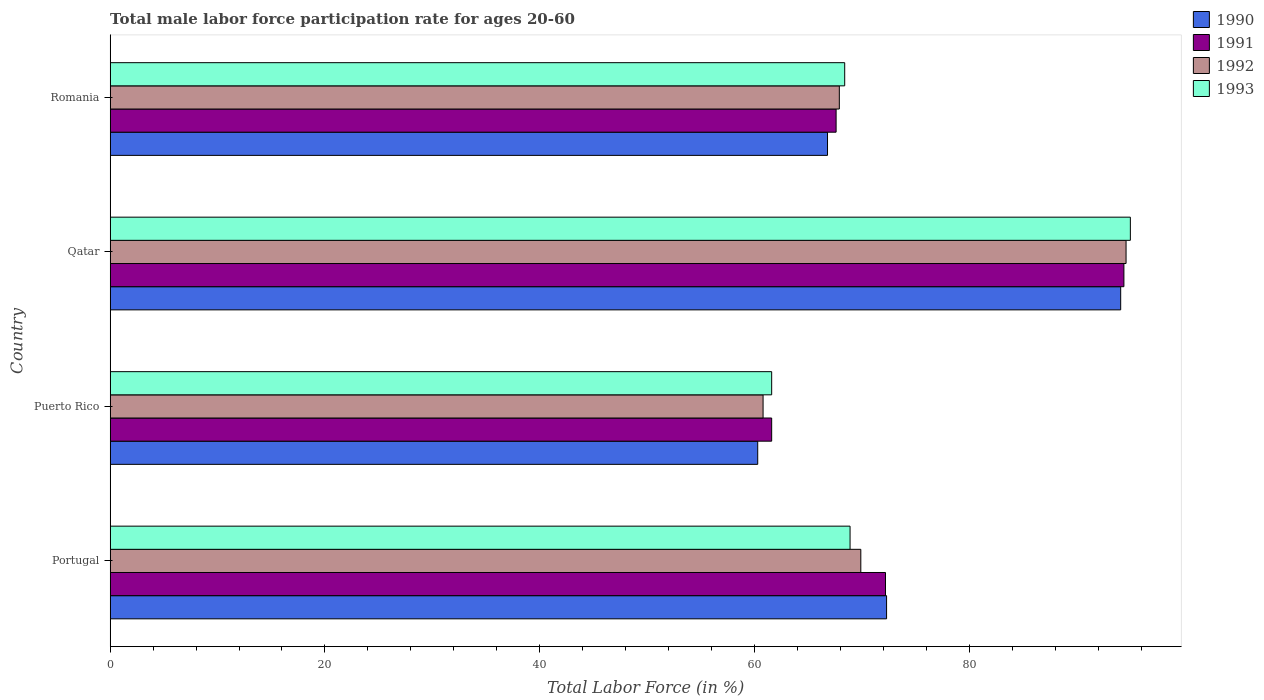How many different coloured bars are there?
Give a very brief answer. 4. Are the number of bars per tick equal to the number of legend labels?
Your response must be concise. Yes. How many bars are there on the 3rd tick from the top?
Your answer should be very brief. 4. How many bars are there on the 1st tick from the bottom?
Your answer should be very brief. 4. What is the male labor force participation rate in 1993 in Puerto Rico?
Provide a short and direct response. 61.6. Across all countries, what is the maximum male labor force participation rate in 1991?
Keep it short and to the point. 94.4. Across all countries, what is the minimum male labor force participation rate in 1990?
Your answer should be compact. 60.3. In which country was the male labor force participation rate in 1992 maximum?
Provide a succinct answer. Qatar. In which country was the male labor force participation rate in 1992 minimum?
Make the answer very short. Puerto Rico. What is the total male labor force participation rate in 1993 in the graph?
Offer a very short reply. 293.9. What is the average male labor force participation rate in 1990 per country?
Provide a succinct answer. 73.38. What is the difference between the male labor force participation rate in 1992 and male labor force participation rate in 1990 in Portugal?
Your answer should be compact. -2.4. What is the ratio of the male labor force participation rate in 1991 in Puerto Rico to that in Qatar?
Provide a short and direct response. 0.65. Is the difference between the male labor force participation rate in 1992 in Portugal and Romania greater than the difference between the male labor force participation rate in 1990 in Portugal and Romania?
Offer a terse response. No. What is the difference between the highest and the second highest male labor force participation rate in 1992?
Your response must be concise. 24.7. What is the difference between the highest and the lowest male labor force participation rate in 1993?
Make the answer very short. 33.4. In how many countries, is the male labor force participation rate in 1993 greater than the average male labor force participation rate in 1993 taken over all countries?
Offer a terse response. 1. Is the sum of the male labor force participation rate in 1991 in Portugal and Qatar greater than the maximum male labor force participation rate in 1993 across all countries?
Make the answer very short. Yes. Is it the case that in every country, the sum of the male labor force participation rate in 1993 and male labor force participation rate in 1990 is greater than the sum of male labor force participation rate in 1992 and male labor force participation rate in 1991?
Your answer should be very brief. No. How many bars are there?
Make the answer very short. 16. Are all the bars in the graph horizontal?
Make the answer very short. Yes. What is the difference between two consecutive major ticks on the X-axis?
Provide a short and direct response. 20. Does the graph contain any zero values?
Keep it short and to the point. No. Does the graph contain grids?
Offer a very short reply. No. How many legend labels are there?
Keep it short and to the point. 4. How are the legend labels stacked?
Give a very brief answer. Vertical. What is the title of the graph?
Provide a succinct answer. Total male labor force participation rate for ages 20-60. What is the label or title of the Y-axis?
Ensure brevity in your answer.  Country. What is the Total Labor Force (in %) of 1990 in Portugal?
Keep it short and to the point. 72.3. What is the Total Labor Force (in %) of 1991 in Portugal?
Offer a terse response. 72.2. What is the Total Labor Force (in %) in 1992 in Portugal?
Give a very brief answer. 69.9. What is the Total Labor Force (in %) in 1993 in Portugal?
Keep it short and to the point. 68.9. What is the Total Labor Force (in %) in 1990 in Puerto Rico?
Make the answer very short. 60.3. What is the Total Labor Force (in %) of 1991 in Puerto Rico?
Offer a terse response. 61.6. What is the Total Labor Force (in %) of 1992 in Puerto Rico?
Give a very brief answer. 60.8. What is the Total Labor Force (in %) in 1993 in Puerto Rico?
Provide a succinct answer. 61.6. What is the Total Labor Force (in %) in 1990 in Qatar?
Your answer should be compact. 94.1. What is the Total Labor Force (in %) in 1991 in Qatar?
Provide a succinct answer. 94.4. What is the Total Labor Force (in %) in 1992 in Qatar?
Offer a terse response. 94.6. What is the Total Labor Force (in %) in 1990 in Romania?
Make the answer very short. 66.8. What is the Total Labor Force (in %) of 1991 in Romania?
Ensure brevity in your answer.  67.6. What is the Total Labor Force (in %) of 1992 in Romania?
Offer a very short reply. 67.9. What is the Total Labor Force (in %) of 1993 in Romania?
Offer a terse response. 68.4. Across all countries, what is the maximum Total Labor Force (in %) in 1990?
Your answer should be very brief. 94.1. Across all countries, what is the maximum Total Labor Force (in %) of 1991?
Provide a short and direct response. 94.4. Across all countries, what is the maximum Total Labor Force (in %) of 1992?
Offer a very short reply. 94.6. Across all countries, what is the maximum Total Labor Force (in %) of 1993?
Offer a terse response. 95. Across all countries, what is the minimum Total Labor Force (in %) of 1990?
Give a very brief answer. 60.3. Across all countries, what is the minimum Total Labor Force (in %) in 1991?
Make the answer very short. 61.6. Across all countries, what is the minimum Total Labor Force (in %) in 1992?
Provide a succinct answer. 60.8. Across all countries, what is the minimum Total Labor Force (in %) in 1993?
Keep it short and to the point. 61.6. What is the total Total Labor Force (in %) of 1990 in the graph?
Provide a succinct answer. 293.5. What is the total Total Labor Force (in %) of 1991 in the graph?
Provide a succinct answer. 295.8. What is the total Total Labor Force (in %) of 1992 in the graph?
Your answer should be very brief. 293.2. What is the total Total Labor Force (in %) of 1993 in the graph?
Offer a very short reply. 293.9. What is the difference between the Total Labor Force (in %) in 1991 in Portugal and that in Puerto Rico?
Offer a terse response. 10.6. What is the difference between the Total Labor Force (in %) of 1993 in Portugal and that in Puerto Rico?
Ensure brevity in your answer.  7.3. What is the difference between the Total Labor Force (in %) of 1990 in Portugal and that in Qatar?
Give a very brief answer. -21.8. What is the difference between the Total Labor Force (in %) of 1991 in Portugal and that in Qatar?
Give a very brief answer. -22.2. What is the difference between the Total Labor Force (in %) in 1992 in Portugal and that in Qatar?
Offer a terse response. -24.7. What is the difference between the Total Labor Force (in %) in 1993 in Portugal and that in Qatar?
Provide a short and direct response. -26.1. What is the difference between the Total Labor Force (in %) of 1990 in Portugal and that in Romania?
Give a very brief answer. 5.5. What is the difference between the Total Labor Force (in %) of 1991 in Portugal and that in Romania?
Offer a terse response. 4.6. What is the difference between the Total Labor Force (in %) of 1992 in Portugal and that in Romania?
Give a very brief answer. 2. What is the difference between the Total Labor Force (in %) in 1993 in Portugal and that in Romania?
Make the answer very short. 0.5. What is the difference between the Total Labor Force (in %) of 1990 in Puerto Rico and that in Qatar?
Make the answer very short. -33.8. What is the difference between the Total Labor Force (in %) of 1991 in Puerto Rico and that in Qatar?
Provide a short and direct response. -32.8. What is the difference between the Total Labor Force (in %) in 1992 in Puerto Rico and that in Qatar?
Provide a short and direct response. -33.8. What is the difference between the Total Labor Force (in %) in 1993 in Puerto Rico and that in Qatar?
Keep it short and to the point. -33.4. What is the difference between the Total Labor Force (in %) of 1991 in Puerto Rico and that in Romania?
Give a very brief answer. -6. What is the difference between the Total Labor Force (in %) in 1990 in Qatar and that in Romania?
Offer a terse response. 27.3. What is the difference between the Total Labor Force (in %) in 1991 in Qatar and that in Romania?
Keep it short and to the point. 26.8. What is the difference between the Total Labor Force (in %) in 1992 in Qatar and that in Romania?
Keep it short and to the point. 26.7. What is the difference between the Total Labor Force (in %) in 1993 in Qatar and that in Romania?
Your answer should be very brief. 26.6. What is the difference between the Total Labor Force (in %) in 1990 in Portugal and the Total Labor Force (in %) in 1993 in Puerto Rico?
Give a very brief answer. 10.7. What is the difference between the Total Labor Force (in %) of 1991 in Portugal and the Total Labor Force (in %) of 1992 in Puerto Rico?
Offer a terse response. 11.4. What is the difference between the Total Labor Force (in %) of 1990 in Portugal and the Total Labor Force (in %) of 1991 in Qatar?
Your response must be concise. -22.1. What is the difference between the Total Labor Force (in %) of 1990 in Portugal and the Total Labor Force (in %) of 1992 in Qatar?
Offer a terse response. -22.3. What is the difference between the Total Labor Force (in %) of 1990 in Portugal and the Total Labor Force (in %) of 1993 in Qatar?
Provide a succinct answer. -22.7. What is the difference between the Total Labor Force (in %) of 1991 in Portugal and the Total Labor Force (in %) of 1992 in Qatar?
Keep it short and to the point. -22.4. What is the difference between the Total Labor Force (in %) of 1991 in Portugal and the Total Labor Force (in %) of 1993 in Qatar?
Offer a terse response. -22.8. What is the difference between the Total Labor Force (in %) of 1992 in Portugal and the Total Labor Force (in %) of 1993 in Qatar?
Offer a very short reply. -25.1. What is the difference between the Total Labor Force (in %) of 1990 in Portugal and the Total Labor Force (in %) of 1991 in Romania?
Give a very brief answer. 4.7. What is the difference between the Total Labor Force (in %) in 1991 in Portugal and the Total Labor Force (in %) in 1992 in Romania?
Your response must be concise. 4.3. What is the difference between the Total Labor Force (in %) of 1992 in Portugal and the Total Labor Force (in %) of 1993 in Romania?
Give a very brief answer. 1.5. What is the difference between the Total Labor Force (in %) in 1990 in Puerto Rico and the Total Labor Force (in %) in 1991 in Qatar?
Your answer should be very brief. -34.1. What is the difference between the Total Labor Force (in %) of 1990 in Puerto Rico and the Total Labor Force (in %) of 1992 in Qatar?
Offer a very short reply. -34.3. What is the difference between the Total Labor Force (in %) of 1990 in Puerto Rico and the Total Labor Force (in %) of 1993 in Qatar?
Provide a succinct answer. -34.7. What is the difference between the Total Labor Force (in %) of 1991 in Puerto Rico and the Total Labor Force (in %) of 1992 in Qatar?
Keep it short and to the point. -33. What is the difference between the Total Labor Force (in %) of 1991 in Puerto Rico and the Total Labor Force (in %) of 1993 in Qatar?
Your answer should be compact. -33.4. What is the difference between the Total Labor Force (in %) in 1992 in Puerto Rico and the Total Labor Force (in %) in 1993 in Qatar?
Keep it short and to the point. -34.2. What is the difference between the Total Labor Force (in %) in 1990 in Qatar and the Total Labor Force (in %) in 1992 in Romania?
Offer a terse response. 26.2. What is the difference between the Total Labor Force (in %) of 1990 in Qatar and the Total Labor Force (in %) of 1993 in Romania?
Your response must be concise. 25.7. What is the difference between the Total Labor Force (in %) in 1992 in Qatar and the Total Labor Force (in %) in 1993 in Romania?
Make the answer very short. 26.2. What is the average Total Labor Force (in %) of 1990 per country?
Offer a terse response. 73.38. What is the average Total Labor Force (in %) in 1991 per country?
Ensure brevity in your answer.  73.95. What is the average Total Labor Force (in %) of 1992 per country?
Offer a terse response. 73.3. What is the average Total Labor Force (in %) in 1993 per country?
Provide a short and direct response. 73.47. What is the difference between the Total Labor Force (in %) of 1990 and Total Labor Force (in %) of 1991 in Portugal?
Your answer should be very brief. 0.1. What is the difference between the Total Labor Force (in %) in 1990 and Total Labor Force (in %) in 1992 in Portugal?
Give a very brief answer. 2.4. What is the difference between the Total Labor Force (in %) of 1990 and Total Labor Force (in %) of 1993 in Portugal?
Offer a very short reply. 3.4. What is the difference between the Total Labor Force (in %) in 1992 and Total Labor Force (in %) in 1993 in Portugal?
Keep it short and to the point. 1. What is the difference between the Total Labor Force (in %) in 1990 and Total Labor Force (in %) in 1992 in Puerto Rico?
Make the answer very short. -0.5. What is the difference between the Total Labor Force (in %) of 1991 and Total Labor Force (in %) of 1992 in Puerto Rico?
Provide a short and direct response. 0.8. What is the difference between the Total Labor Force (in %) in 1991 and Total Labor Force (in %) in 1993 in Puerto Rico?
Provide a short and direct response. 0. What is the difference between the Total Labor Force (in %) of 1992 and Total Labor Force (in %) of 1993 in Puerto Rico?
Your answer should be compact. -0.8. What is the difference between the Total Labor Force (in %) in 1990 and Total Labor Force (in %) in 1991 in Qatar?
Your answer should be very brief. -0.3. What is the difference between the Total Labor Force (in %) in 1990 and Total Labor Force (in %) in 1993 in Qatar?
Your answer should be very brief. -0.9. What is the difference between the Total Labor Force (in %) of 1990 and Total Labor Force (in %) of 1992 in Romania?
Give a very brief answer. -1.1. What is the difference between the Total Labor Force (in %) in 1992 and Total Labor Force (in %) in 1993 in Romania?
Provide a short and direct response. -0.5. What is the ratio of the Total Labor Force (in %) in 1990 in Portugal to that in Puerto Rico?
Give a very brief answer. 1.2. What is the ratio of the Total Labor Force (in %) in 1991 in Portugal to that in Puerto Rico?
Your answer should be very brief. 1.17. What is the ratio of the Total Labor Force (in %) in 1992 in Portugal to that in Puerto Rico?
Make the answer very short. 1.15. What is the ratio of the Total Labor Force (in %) of 1993 in Portugal to that in Puerto Rico?
Your answer should be very brief. 1.12. What is the ratio of the Total Labor Force (in %) in 1990 in Portugal to that in Qatar?
Keep it short and to the point. 0.77. What is the ratio of the Total Labor Force (in %) of 1991 in Portugal to that in Qatar?
Provide a short and direct response. 0.76. What is the ratio of the Total Labor Force (in %) of 1992 in Portugal to that in Qatar?
Offer a very short reply. 0.74. What is the ratio of the Total Labor Force (in %) of 1993 in Portugal to that in Qatar?
Ensure brevity in your answer.  0.73. What is the ratio of the Total Labor Force (in %) in 1990 in Portugal to that in Romania?
Your answer should be compact. 1.08. What is the ratio of the Total Labor Force (in %) in 1991 in Portugal to that in Romania?
Offer a terse response. 1.07. What is the ratio of the Total Labor Force (in %) in 1992 in Portugal to that in Romania?
Provide a succinct answer. 1.03. What is the ratio of the Total Labor Force (in %) of 1993 in Portugal to that in Romania?
Your answer should be very brief. 1.01. What is the ratio of the Total Labor Force (in %) in 1990 in Puerto Rico to that in Qatar?
Your answer should be compact. 0.64. What is the ratio of the Total Labor Force (in %) in 1991 in Puerto Rico to that in Qatar?
Your answer should be very brief. 0.65. What is the ratio of the Total Labor Force (in %) of 1992 in Puerto Rico to that in Qatar?
Your answer should be compact. 0.64. What is the ratio of the Total Labor Force (in %) of 1993 in Puerto Rico to that in Qatar?
Your answer should be very brief. 0.65. What is the ratio of the Total Labor Force (in %) in 1990 in Puerto Rico to that in Romania?
Keep it short and to the point. 0.9. What is the ratio of the Total Labor Force (in %) in 1991 in Puerto Rico to that in Romania?
Your answer should be very brief. 0.91. What is the ratio of the Total Labor Force (in %) of 1992 in Puerto Rico to that in Romania?
Your answer should be very brief. 0.9. What is the ratio of the Total Labor Force (in %) in 1993 in Puerto Rico to that in Romania?
Provide a short and direct response. 0.9. What is the ratio of the Total Labor Force (in %) of 1990 in Qatar to that in Romania?
Provide a succinct answer. 1.41. What is the ratio of the Total Labor Force (in %) in 1991 in Qatar to that in Romania?
Offer a terse response. 1.4. What is the ratio of the Total Labor Force (in %) of 1992 in Qatar to that in Romania?
Offer a terse response. 1.39. What is the ratio of the Total Labor Force (in %) in 1993 in Qatar to that in Romania?
Give a very brief answer. 1.39. What is the difference between the highest and the second highest Total Labor Force (in %) of 1990?
Offer a terse response. 21.8. What is the difference between the highest and the second highest Total Labor Force (in %) in 1992?
Offer a terse response. 24.7. What is the difference between the highest and the second highest Total Labor Force (in %) of 1993?
Offer a terse response. 26.1. What is the difference between the highest and the lowest Total Labor Force (in %) of 1990?
Ensure brevity in your answer.  33.8. What is the difference between the highest and the lowest Total Labor Force (in %) of 1991?
Provide a short and direct response. 32.8. What is the difference between the highest and the lowest Total Labor Force (in %) in 1992?
Offer a very short reply. 33.8. What is the difference between the highest and the lowest Total Labor Force (in %) of 1993?
Make the answer very short. 33.4. 